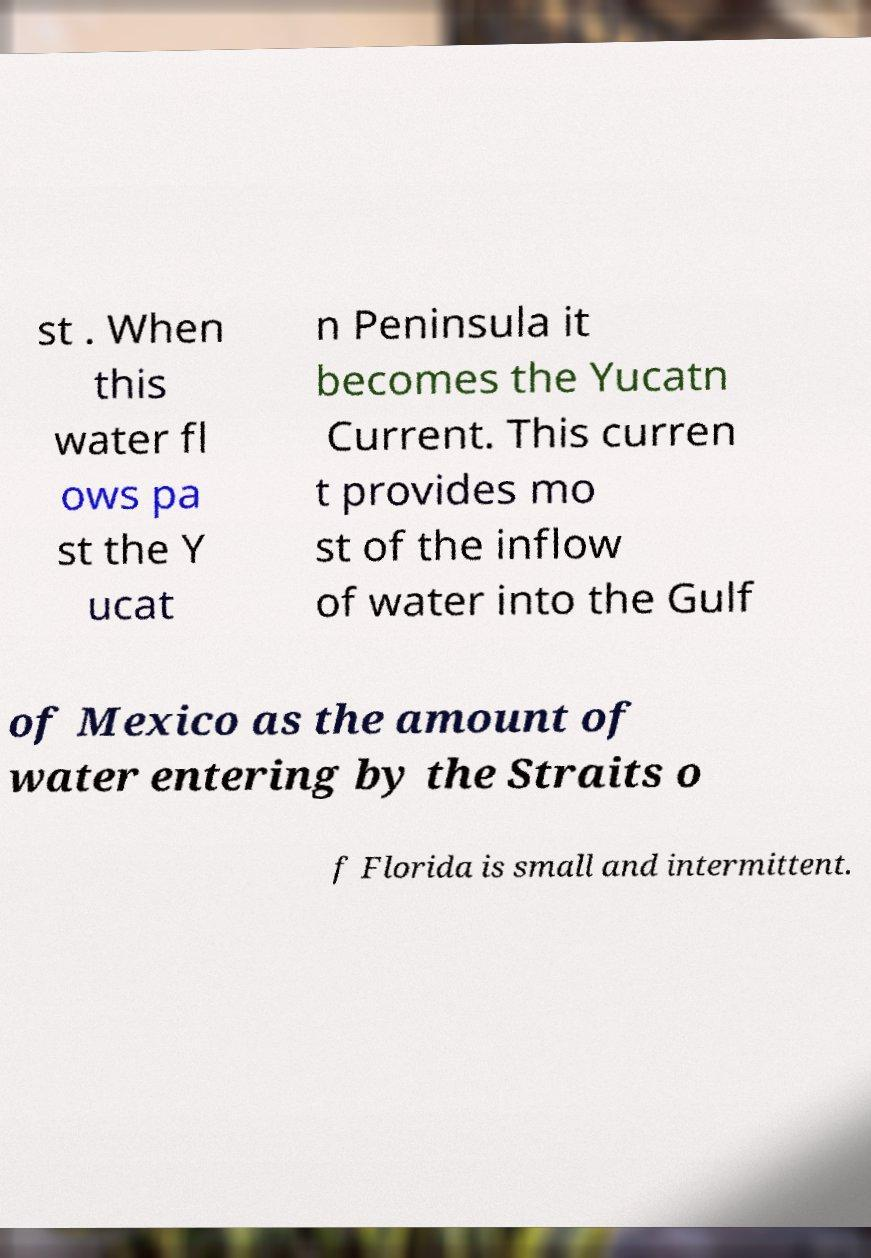What messages or text are displayed in this image? I need them in a readable, typed format. st . When this water fl ows pa st the Y ucat n Peninsula it becomes the Yucatn Current. This curren t provides mo st of the inflow of water into the Gulf of Mexico as the amount of water entering by the Straits o f Florida is small and intermittent. 